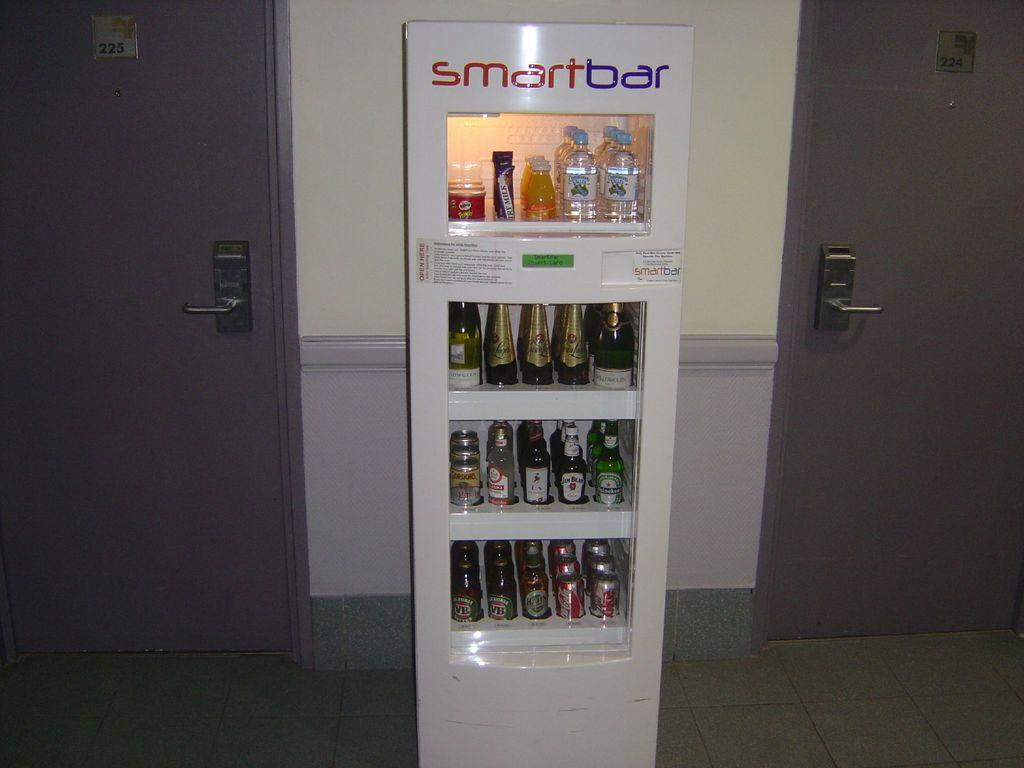What is on the rack that is visible in the image? There are bottles, chocolate, and tins on the rack. Where is the rack located in the image? The rack is placed on the floor. What else can be seen in the image besides the rack? There are doors visible in the image. Can you see a yak walking through the doors in the image? No, there is no yak present in the image, and no animals are visible. 